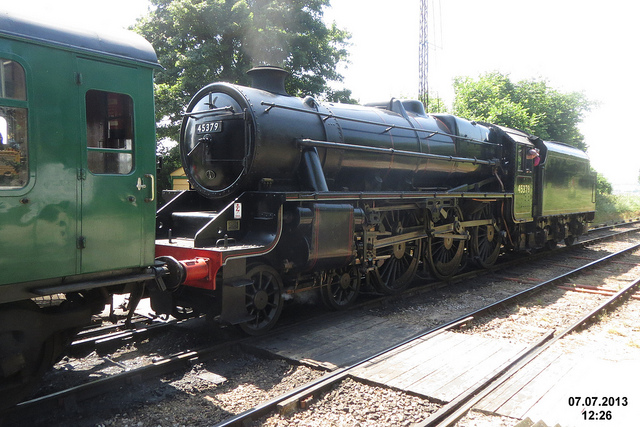Can you describe the era from which this train comes? Certainly! The steam locomotive in the image hails from a transformative period in history known as the Industrial Revolution, which occurred between the 18th and 19th centuries. The design suggests it is likely from the early to mid-20th century, a time when steam was still the predominant source of power for railways. These machines symbolized the advancements in transportation and industry, helping to move goods and people more efficiently than ever before. 